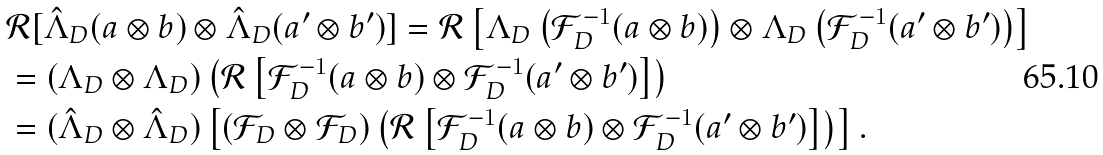<formula> <loc_0><loc_0><loc_500><loc_500>& { \mathcal { R } } [ \hat { \Lambda } _ { D } ( a \otimes b ) \otimes \hat { \Lambda } _ { D } ( a ^ { \prime } \otimes b ^ { \prime } ) ] = { \mathcal { R } } \left [ { \Lambda } _ { D } \left ( { \mathcal { F } } ^ { - 1 } _ { D } ( a \otimes b ) \right ) \otimes { \Lambda } _ { D } \left ( { \mathcal { F } } ^ { - 1 } _ { D } ( a ^ { \prime } \otimes b ^ { \prime } ) \right ) \right ] \\ & = ( \Lambda _ { D } \otimes \Lambda _ { D } ) \left ( { \mathcal { R } } \left [ { \mathcal { F } } ^ { - 1 } _ { D } ( a \otimes b ) \otimes { \mathcal { F } } ^ { - 1 } _ { D } ( a ^ { \prime } \otimes b ^ { \prime } ) \right ] \right ) \\ & = ( \hat { \Lambda } _ { D } \otimes \hat { \Lambda } _ { D } ) \left [ ( { \mathcal { F } } _ { D } \otimes { \mathcal { F } } _ { D } ) \left ( { \mathcal { R } } \left [ { \mathcal { F } } ^ { - 1 } _ { D } ( a \otimes b ) \otimes { \mathcal { F } } ^ { - 1 } _ { D } ( a ^ { \prime } \otimes b ^ { \prime } ) \right ] \right ) \right ] .</formula> 